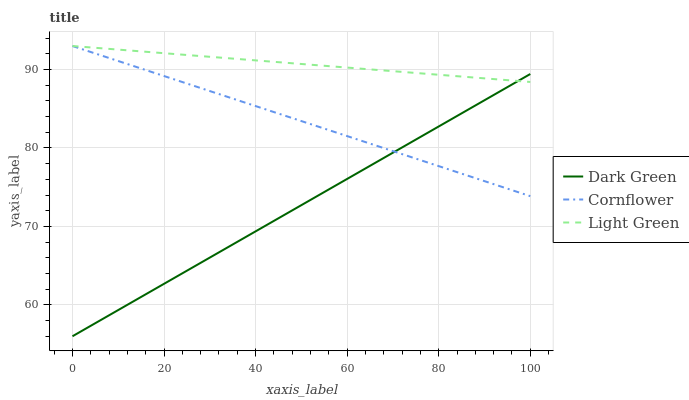Does Light Green have the minimum area under the curve?
Answer yes or no. No. Does Dark Green have the maximum area under the curve?
Answer yes or no. No. Is Dark Green the smoothest?
Answer yes or no. No. Is Light Green the roughest?
Answer yes or no. No. Does Light Green have the lowest value?
Answer yes or no. No. Does Dark Green have the highest value?
Answer yes or no. No. 